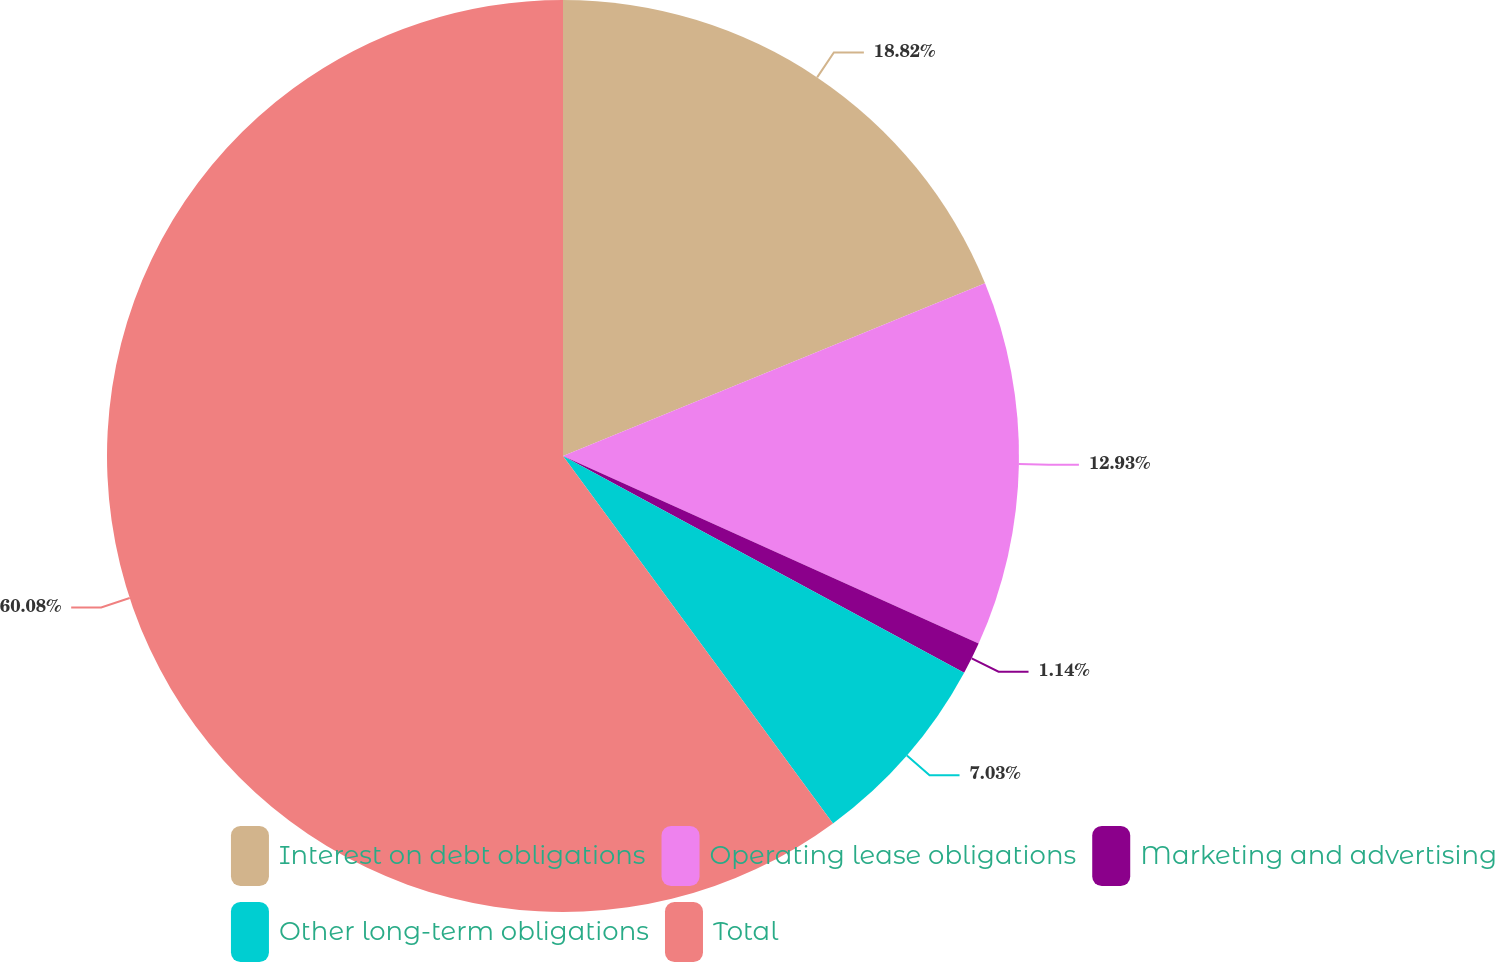Convert chart to OTSL. <chart><loc_0><loc_0><loc_500><loc_500><pie_chart><fcel>Interest on debt obligations<fcel>Operating lease obligations<fcel>Marketing and advertising<fcel>Other long-term obligations<fcel>Total<nl><fcel>18.82%<fcel>12.93%<fcel>1.14%<fcel>7.03%<fcel>60.09%<nl></chart> 